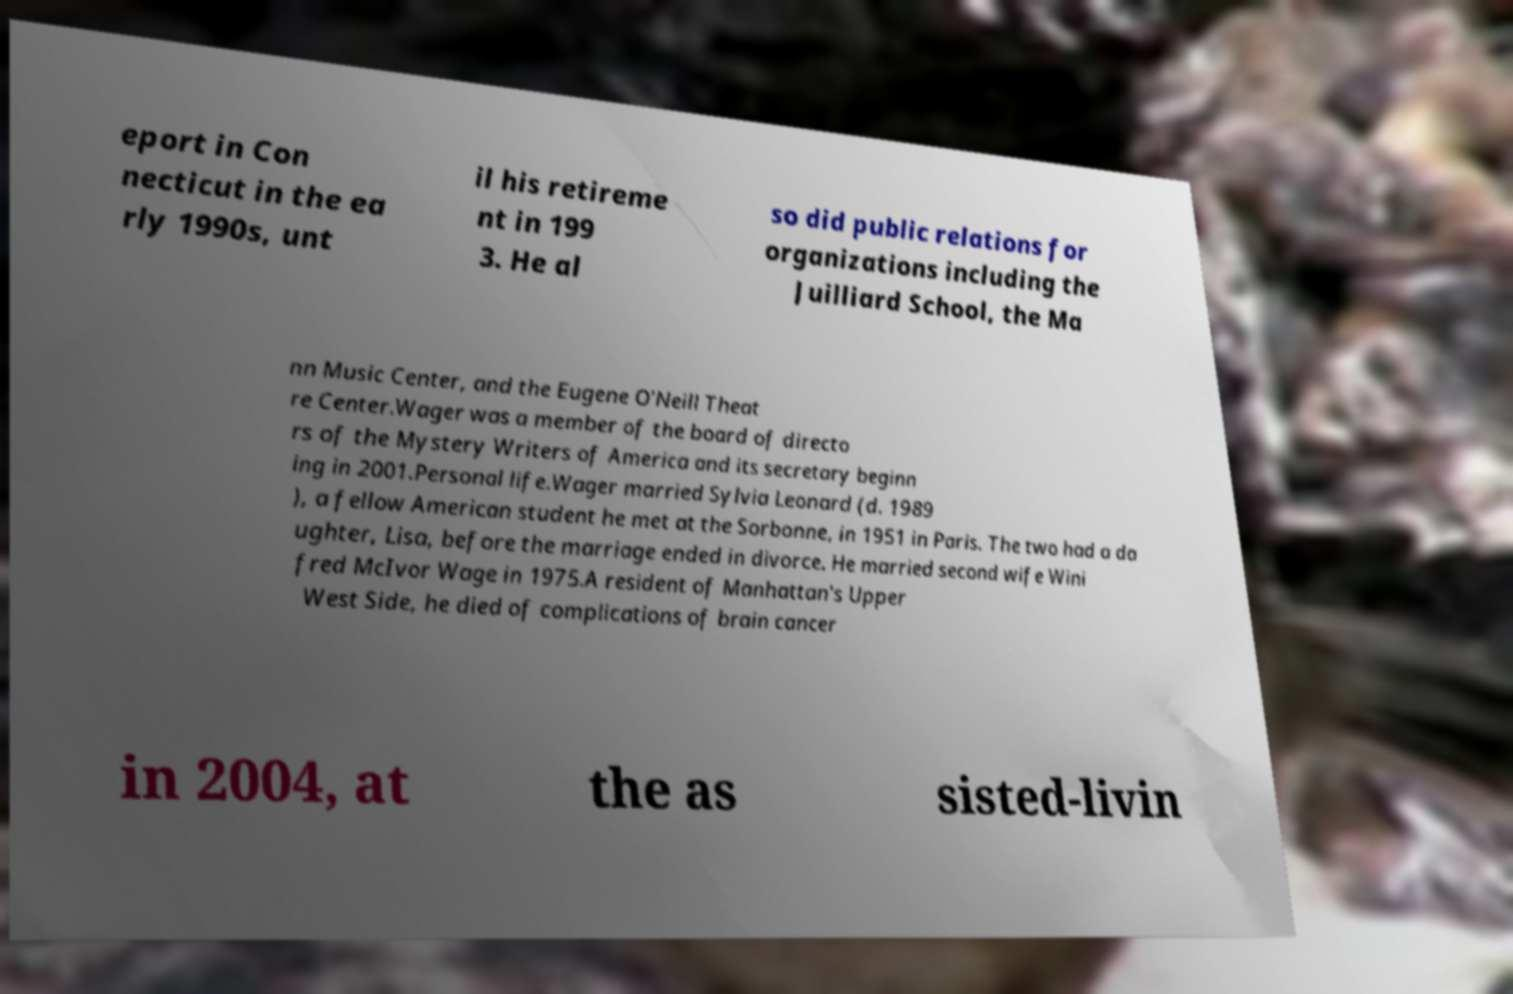Could you extract and type out the text from this image? eport in Con necticut in the ea rly 1990s, unt il his retireme nt in 199 3. He al so did public relations for organizations including the Juilliard School, the Ma nn Music Center, and the Eugene O'Neill Theat re Center.Wager was a member of the board of directo rs of the Mystery Writers of America and its secretary beginn ing in 2001.Personal life.Wager married Sylvia Leonard (d. 1989 ), a fellow American student he met at the Sorbonne, in 1951 in Paris. The two had a da ughter, Lisa, before the marriage ended in divorce. He married second wife Wini fred McIvor Wage in 1975.A resident of Manhattan's Upper West Side, he died of complications of brain cancer in 2004, at the as sisted-livin 